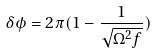Convert formula to latex. <formula><loc_0><loc_0><loc_500><loc_500>\delta \phi = 2 \pi ( 1 - \frac { 1 } { \sqrt { \Omega ^ { 2 } f } } )</formula> 